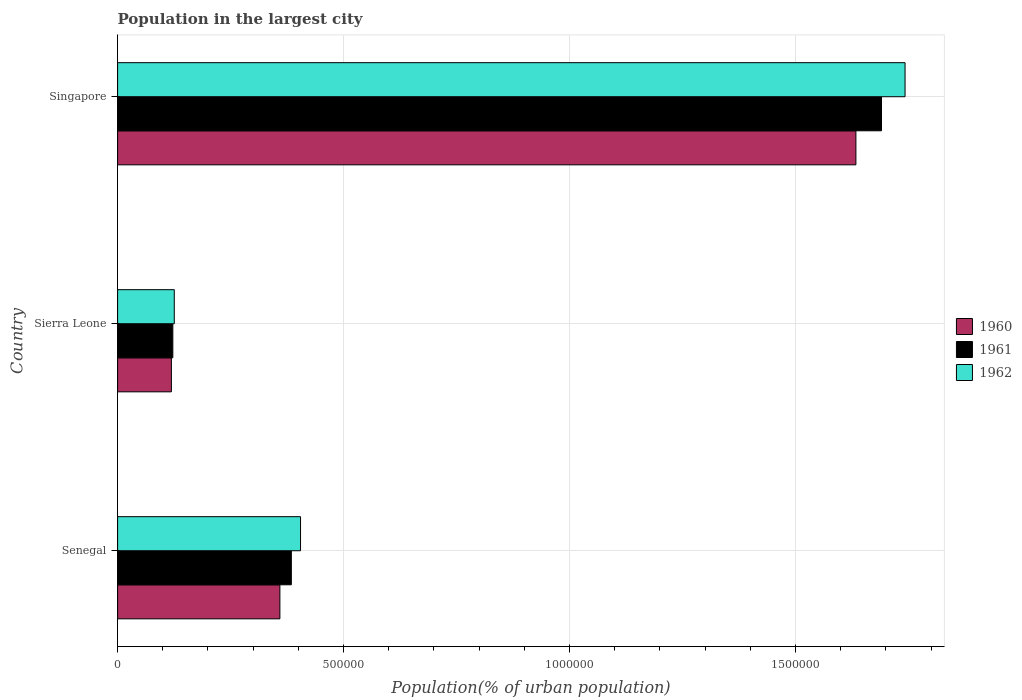How many different coloured bars are there?
Make the answer very short. 3. How many groups of bars are there?
Your answer should be compact. 3. Are the number of bars per tick equal to the number of legend labels?
Your response must be concise. Yes. How many bars are there on the 1st tick from the top?
Provide a short and direct response. 3. How many bars are there on the 1st tick from the bottom?
Provide a short and direct response. 3. What is the label of the 1st group of bars from the top?
Your answer should be compact. Singapore. In how many cases, is the number of bars for a given country not equal to the number of legend labels?
Keep it short and to the point. 0. What is the population in the largest city in 1960 in Singapore?
Offer a very short reply. 1.63e+06. Across all countries, what is the maximum population in the largest city in 1962?
Keep it short and to the point. 1.74e+06. Across all countries, what is the minimum population in the largest city in 1960?
Offer a terse response. 1.19e+05. In which country was the population in the largest city in 1961 maximum?
Give a very brief answer. Singapore. In which country was the population in the largest city in 1961 minimum?
Ensure brevity in your answer.  Sierra Leone. What is the total population in the largest city in 1961 in the graph?
Keep it short and to the point. 2.20e+06. What is the difference between the population in the largest city in 1960 in Sierra Leone and that in Singapore?
Provide a short and direct response. -1.51e+06. What is the difference between the population in the largest city in 1962 in Sierra Leone and the population in the largest city in 1961 in Singapore?
Ensure brevity in your answer.  -1.56e+06. What is the average population in the largest city in 1962 per country?
Give a very brief answer. 7.58e+05. What is the difference between the population in the largest city in 1961 and population in the largest city in 1960 in Singapore?
Ensure brevity in your answer.  5.66e+04. What is the ratio of the population in the largest city in 1961 in Sierra Leone to that in Singapore?
Your response must be concise. 0.07. Is the difference between the population in the largest city in 1961 in Sierra Leone and Singapore greater than the difference between the population in the largest city in 1960 in Sierra Leone and Singapore?
Keep it short and to the point. No. What is the difference between the highest and the second highest population in the largest city in 1961?
Offer a terse response. 1.31e+06. What is the difference between the highest and the lowest population in the largest city in 1962?
Provide a succinct answer. 1.62e+06. Is the sum of the population in the largest city in 1962 in Sierra Leone and Singapore greater than the maximum population in the largest city in 1960 across all countries?
Offer a very short reply. Yes. What does the 2nd bar from the bottom in Sierra Leone represents?
Offer a very short reply. 1961. Are all the bars in the graph horizontal?
Your response must be concise. Yes. What is the difference between two consecutive major ticks on the X-axis?
Provide a short and direct response. 5.00e+05. Does the graph contain any zero values?
Ensure brevity in your answer.  No. Does the graph contain grids?
Ensure brevity in your answer.  Yes. Where does the legend appear in the graph?
Ensure brevity in your answer.  Center right. How many legend labels are there?
Provide a succinct answer. 3. How are the legend labels stacked?
Make the answer very short. Vertical. What is the title of the graph?
Give a very brief answer. Population in the largest city. What is the label or title of the X-axis?
Give a very brief answer. Population(% of urban population). What is the Population(% of urban population) of 1960 in Senegal?
Ensure brevity in your answer.  3.59e+05. What is the Population(% of urban population) of 1961 in Senegal?
Ensure brevity in your answer.  3.84e+05. What is the Population(% of urban population) of 1962 in Senegal?
Your answer should be compact. 4.05e+05. What is the Population(% of urban population) in 1960 in Sierra Leone?
Your answer should be very brief. 1.19e+05. What is the Population(% of urban population) of 1961 in Sierra Leone?
Keep it short and to the point. 1.22e+05. What is the Population(% of urban population) in 1962 in Sierra Leone?
Ensure brevity in your answer.  1.25e+05. What is the Population(% of urban population) in 1960 in Singapore?
Offer a terse response. 1.63e+06. What is the Population(% of urban population) of 1961 in Singapore?
Give a very brief answer. 1.69e+06. What is the Population(% of urban population) of 1962 in Singapore?
Offer a very short reply. 1.74e+06. Across all countries, what is the maximum Population(% of urban population) of 1960?
Your answer should be very brief. 1.63e+06. Across all countries, what is the maximum Population(% of urban population) of 1961?
Make the answer very short. 1.69e+06. Across all countries, what is the maximum Population(% of urban population) in 1962?
Your response must be concise. 1.74e+06. Across all countries, what is the minimum Population(% of urban population) in 1960?
Keep it short and to the point. 1.19e+05. Across all countries, what is the minimum Population(% of urban population) of 1961?
Provide a short and direct response. 1.22e+05. Across all countries, what is the minimum Population(% of urban population) in 1962?
Provide a short and direct response. 1.25e+05. What is the total Population(% of urban population) of 1960 in the graph?
Offer a terse response. 2.11e+06. What is the total Population(% of urban population) in 1961 in the graph?
Offer a terse response. 2.20e+06. What is the total Population(% of urban population) of 1962 in the graph?
Make the answer very short. 2.27e+06. What is the difference between the Population(% of urban population) in 1960 in Senegal and that in Sierra Leone?
Your answer should be very brief. 2.40e+05. What is the difference between the Population(% of urban population) in 1961 in Senegal and that in Sierra Leone?
Provide a short and direct response. 2.62e+05. What is the difference between the Population(% of urban population) of 1962 in Senegal and that in Sierra Leone?
Your answer should be compact. 2.79e+05. What is the difference between the Population(% of urban population) of 1960 in Senegal and that in Singapore?
Your answer should be compact. -1.27e+06. What is the difference between the Population(% of urban population) of 1961 in Senegal and that in Singapore?
Keep it short and to the point. -1.31e+06. What is the difference between the Population(% of urban population) of 1962 in Senegal and that in Singapore?
Ensure brevity in your answer.  -1.34e+06. What is the difference between the Population(% of urban population) of 1960 in Sierra Leone and that in Singapore?
Give a very brief answer. -1.51e+06. What is the difference between the Population(% of urban population) of 1961 in Sierra Leone and that in Singapore?
Ensure brevity in your answer.  -1.57e+06. What is the difference between the Population(% of urban population) of 1962 in Sierra Leone and that in Singapore?
Provide a succinct answer. -1.62e+06. What is the difference between the Population(% of urban population) of 1960 in Senegal and the Population(% of urban population) of 1961 in Sierra Leone?
Provide a short and direct response. 2.37e+05. What is the difference between the Population(% of urban population) of 1960 in Senegal and the Population(% of urban population) of 1962 in Sierra Leone?
Provide a succinct answer. 2.34e+05. What is the difference between the Population(% of urban population) in 1961 in Senegal and the Population(% of urban population) in 1962 in Sierra Leone?
Make the answer very short. 2.59e+05. What is the difference between the Population(% of urban population) of 1960 in Senegal and the Population(% of urban population) of 1961 in Singapore?
Provide a short and direct response. -1.33e+06. What is the difference between the Population(% of urban population) of 1960 in Senegal and the Population(% of urban population) of 1962 in Singapore?
Provide a succinct answer. -1.38e+06. What is the difference between the Population(% of urban population) of 1961 in Senegal and the Population(% of urban population) of 1962 in Singapore?
Provide a short and direct response. -1.36e+06. What is the difference between the Population(% of urban population) in 1960 in Sierra Leone and the Population(% of urban population) in 1961 in Singapore?
Provide a succinct answer. -1.57e+06. What is the difference between the Population(% of urban population) in 1960 in Sierra Leone and the Population(% of urban population) in 1962 in Singapore?
Your answer should be compact. -1.62e+06. What is the difference between the Population(% of urban population) of 1961 in Sierra Leone and the Population(% of urban population) of 1962 in Singapore?
Your answer should be very brief. -1.62e+06. What is the average Population(% of urban population) of 1960 per country?
Ensure brevity in your answer.  7.04e+05. What is the average Population(% of urban population) in 1961 per country?
Give a very brief answer. 7.32e+05. What is the average Population(% of urban population) of 1962 per country?
Provide a short and direct response. 7.58e+05. What is the difference between the Population(% of urban population) in 1960 and Population(% of urban population) in 1961 in Senegal?
Make the answer very short. -2.53e+04. What is the difference between the Population(% of urban population) in 1960 and Population(% of urban population) in 1962 in Senegal?
Your response must be concise. -4.57e+04. What is the difference between the Population(% of urban population) in 1961 and Population(% of urban population) in 1962 in Senegal?
Provide a short and direct response. -2.04e+04. What is the difference between the Population(% of urban population) of 1960 and Population(% of urban population) of 1961 in Sierra Leone?
Provide a succinct answer. -3159. What is the difference between the Population(% of urban population) of 1960 and Population(% of urban population) of 1962 in Sierra Leone?
Keep it short and to the point. -6406. What is the difference between the Population(% of urban population) in 1961 and Population(% of urban population) in 1962 in Sierra Leone?
Provide a short and direct response. -3247. What is the difference between the Population(% of urban population) of 1960 and Population(% of urban population) of 1961 in Singapore?
Offer a terse response. -5.66e+04. What is the difference between the Population(% of urban population) of 1960 and Population(% of urban population) of 1962 in Singapore?
Make the answer very short. -1.09e+05. What is the difference between the Population(% of urban population) of 1961 and Population(% of urban population) of 1962 in Singapore?
Provide a succinct answer. -5.21e+04. What is the ratio of the Population(% of urban population) in 1960 in Senegal to that in Sierra Leone?
Offer a terse response. 3.02. What is the ratio of the Population(% of urban population) of 1961 in Senegal to that in Sierra Leone?
Make the answer very short. 3.15. What is the ratio of the Population(% of urban population) in 1962 in Senegal to that in Sierra Leone?
Keep it short and to the point. 3.23. What is the ratio of the Population(% of urban population) of 1960 in Senegal to that in Singapore?
Offer a very short reply. 0.22. What is the ratio of the Population(% of urban population) in 1961 in Senegal to that in Singapore?
Your answer should be very brief. 0.23. What is the ratio of the Population(% of urban population) in 1962 in Senegal to that in Singapore?
Ensure brevity in your answer.  0.23. What is the ratio of the Population(% of urban population) of 1960 in Sierra Leone to that in Singapore?
Your answer should be compact. 0.07. What is the ratio of the Population(% of urban population) of 1961 in Sierra Leone to that in Singapore?
Offer a very short reply. 0.07. What is the ratio of the Population(% of urban population) of 1962 in Sierra Leone to that in Singapore?
Give a very brief answer. 0.07. What is the difference between the highest and the second highest Population(% of urban population) of 1960?
Provide a succinct answer. 1.27e+06. What is the difference between the highest and the second highest Population(% of urban population) in 1961?
Offer a terse response. 1.31e+06. What is the difference between the highest and the second highest Population(% of urban population) in 1962?
Provide a succinct answer. 1.34e+06. What is the difference between the highest and the lowest Population(% of urban population) in 1960?
Provide a succinct answer. 1.51e+06. What is the difference between the highest and the lowest Population(% of urban population) of 1961?
Provide a short and direct response. 1.57e+06. What is the difference between the highest and the lowest Population(% of urban population) of 1962?
Provide a short and direct response. 1.62e+06. 